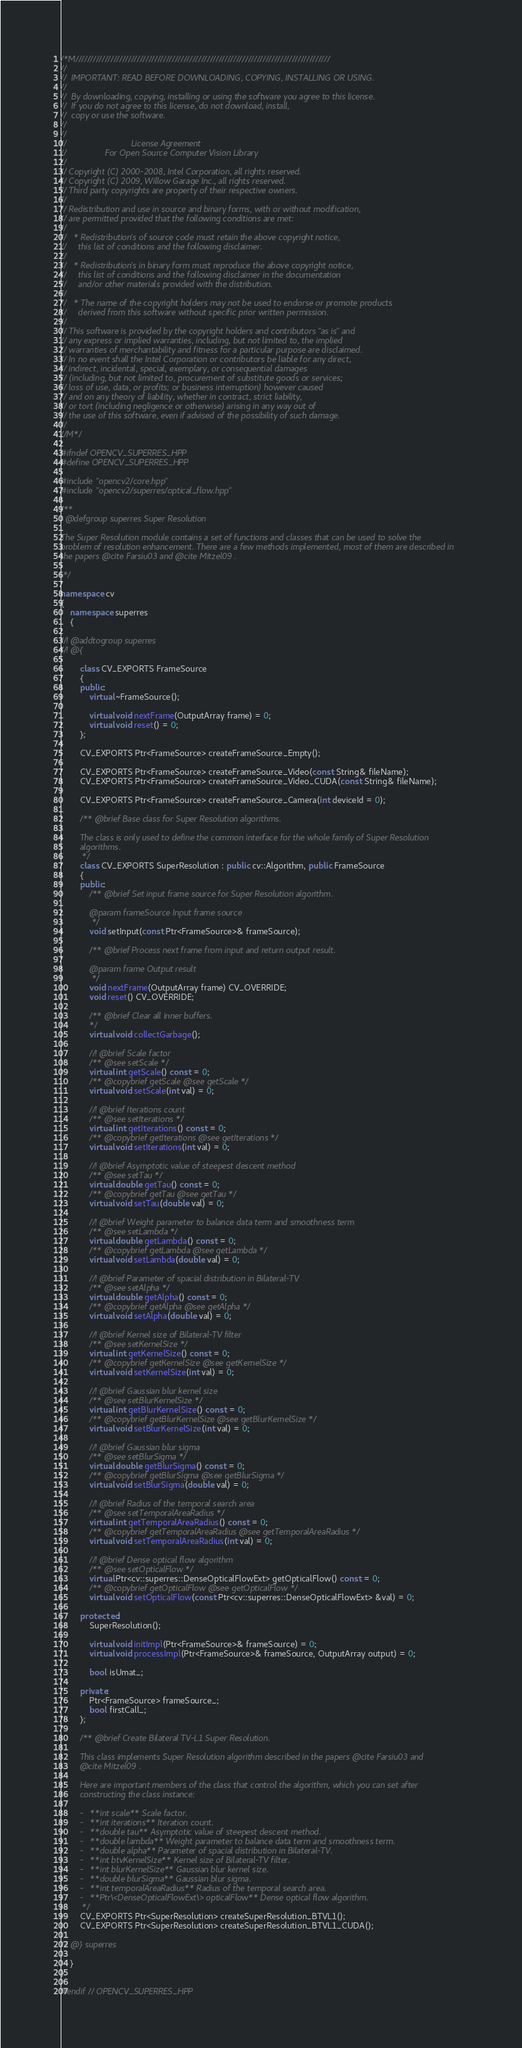<code> <loc_0><loc_0><loc_500><loc_500><_C++_>/*M///////////////////////////////////////////////////////////////////////////////////////
//
//  IMPORTANT: READ BEFORE DOWNLOADING, COPYING, INSTALLING OR USING.
//
//  By downloading, copying, installing or using the software you agree to this license.
//  If you do not agree to this license, do not download, install,
//  copy or use the software.
//
//
//                           License Agreement
//                For Open Source Computer Vision Library
//
// Copyright (C) 2000-2008, Intel Corporation, all rights reserved.
// Copyright (C) 2009, Willow Garage Inc., all rights reserved.
// Third party copyrights are property of their respective owners.
//
// Redistribution and use in source and binary forms, with or without modification,
// are permitted provided that the following conditions are met:
//
//   * Redistribution's of source code must retain the above copyright notice,
//     this list of conditions and the following disclaimer.
//
//   * Redistribution's in binary form must reproduce the above copyright notice,
//     this list of conditions and the following disclaimer in the documentation
//     and/or other materials provided with the distribution.
//
//   * The name of the copyright holders may not be used to endorse or promote products
//     derived from this software without specific prior written permission.
//
// This software is provided by the copyright holders and contributors "as is" and
// any express or implied warranties, including, but not limited to, the implied
// warranties of merchantability and fitness for a particular purpose are disclaimed.
// In no event shall the Intel Corporation or contributors be liable for any direct,
// indirect, incidental, special, exemplary, or consequential damages
// (including, but not limited to, procurement of substitute goods or services;
// loss of use, data, or profits; or business interruption) however caused
// and on any theory of liability, whether in contract, strict liability,
// or tort (including negligence or otherwise) arising in any way out of
// the use of this software, even if advised of the possibility of such damage.
//
//M*/

#ifndef OPENCV_SUPERRES_HPP
#define OPENCV_SUPERRES_HPP

#include "opencv2/core.hpp"
#include "opencv2/superres/optical_flow.hpp"

/**
  @defgroup superres Super Resolution

The Super Resolution module contains a set of functions and classes that can be used to solve the
problem of resolution enhancement. There are a few methods implemented, most of them are described in
the papers @cite Farsiu03 and @cite Mitzel09 .

 */

namespace cv
{
    namespace superres
    {

//! @addtogroup superres
//! @{

        class CV_EXPORTS FrameSource
        {
        public:
            virtual ~FrameSource();

            virtual void nextFrame(OutputArray frame) = 0;
            virtual void reset() = 0;
        };

        CV_EXPORTS Ptr<FrameSource> createFrameSource_Empty();

        CV_EXPORTS Ptr<FrameSource> createFrameSource_Video(const String& fileName);
        CV_EXPORTS Ptr<FrameSource> createFrameSource_Video_CUDA(const String& fileName);

        CV_EXPORTS Ptr<FrameSource> createFrameSource_Camera(int deviceId = 0);

        /** @brief Base class for Super Resolution algorithms.

        The class is only used to define the common interface for the whole family of Super Resolution
        algorithms.
         */
        class CV_EXPORTS SuperResolution : public cv::Algorithm, public FrameSource
        {
        public:
            /** @brief Set input frame source for Super Resolution algorithm.

            @param frameSource Input frame source
             */
            void setInput(const Ptr<FrameSource>& frameSource);

            /** @brief Process next frame from input and return output result.

            @param frame Output result
             */
            void nextFrame(OutputArray frame) CV_OVERRIDE;
            void reset() CV_OVERRIDE;

            /** @brief Clear all inner buffers.
            */
            virtual void collectGarbage();

            //! @brief Scale factor
            /** @see setScale */
            virtual int getScale() const = 0;
            /** @copybrief getScale @see getScale */
            virtual void setScale(int val) = 0;

            //! @brief Iterations count
            /** @see setIterations */
            virtual int getIterations() const = 0;
            /** @copybrief getIterations @see getIterations */
            virtual void setIterations(int val) = 0;

            //! @brief Asymptotic value of steepest descent method
            /** @see setTau */
            virtual double getTau() const = 0;
            /** @copybrief getTau @see getTau */
            virtual void setTau(double val) = 0;

            //! @brief Weight parameter to balance data term and smoothness term
            /** @see setLambda */
            virtual double getLambda() const = 0;
            /** @copybrief getLambda @see getLambda */
            virtual void setLambda(double val) = 0;

            //! @brief Parameter of spacial distribution in Bilateral-TV
            /** @see setAlpha */
            virtual double getAlpha() const = 0;
            /** @copybrief getAlpha @see getAlpha */
            virtual void setAlpha(double val) = 0;

            //! @brief Kernel size of Bilateral-TV filter
            /** @see setKernelSize */
            virtual int getKernelSize() const = 0;
            /** @copybrief getKernelSize @see getKernelSize */
            virtual void setKernelSize(int val) = 0;

            //! @brief Gaussian blur kernel size
            /** @see setBlurKernelSize */
            virtual int getBlurKernelSize() const = 0;
            /** @copybrief getBlurKernelSize @see getBlurKernelSize */
            virtual void setBlurKernelSize(int val) = 0;

            //! @brief Gaussian blur sigma
            /** @see setBlurSigma */
            virtual double getBlurSigma() const = 0;
            /** @copybrief getBlurSigma @see getBlurSigma */
            virtual void setBlurSigma(double val) = 0;

            //! @brief Radius of the temporal search area
            /** @see setTemporalAreaRadius */
            virtual int getTemporalAreaRadius() const = 0;
            /** @copybrief getTemporalAreaRadius @see getTemporalAreaRadius */
            virtual void setTemporalAreaRadius(int val) = 0;

            //! @brief Dense optical flow algorithm
            /** @see setOpticalFlow */
            virtual Ptr<cv::superres::DenseOpticalFlowExt> getOpticalFlow() const = 0;
            /** @copybrief getOpticalFlow @see getOpticalFlow */
            virtual void setOpticalFlow(const Ptr<cv::superres::DenseOpticalFlowExt> &val) = 0;

        protected:
            SuperResolution();

            virtual void initImpl(Ptr<FrameSource>& frameSource) = 0;
            virtual void processImpl(Ptr<FrameSource>& frameSource, OutputArray output) = 0;

            bool isUmat_;

        private:
            Ptr<FrameSource> frameSource_;
            bool firstCall_;
        };

        /** @brief Create Bilateral TV-L1 Super Resolution.

        This class implements Super Resolution algorithm described in the papers @cite Farsiu03 and
        @cite Mitzel09 .

        Here are important members of the class that control the algorithm, which you can set after
        constructing the class instance:

        -   **int scale** Scale factor.
        -   **int iterations** Iteration count.
        -   **double tau** Asymptotic value of steepest descent method.
        -   **double lambda** Weight parameter to balance data term and smoothness term.
        -   **double alpha** Parameter of spacial distribution in Bilateral-TV.
        -   **int btvKernelSize** Kernel size of Bilateral-TV filter.
        -   **int blurKernelSize** Gaussian blur kernel size.
        -   **double blurSigma** Gaussian blur sigma.
        -   **int temporalAreaRadius** Radius of the temporal search area.
        -   **Ptr\<DenseOpticalFlowExt\> opticalFlow** Dense optical flow algorithm.
         */
        CV_EXPORTS Ptr<SuperResolution> createSuperResolution_BTVL1();
        CV_EXPORTS Ptr<SuperResolution> createSuperResolution_BTVL1_CUDA();

//! @} superres

    }
}

#endif // OPENCV_SUPERRES_HPP
</code> 